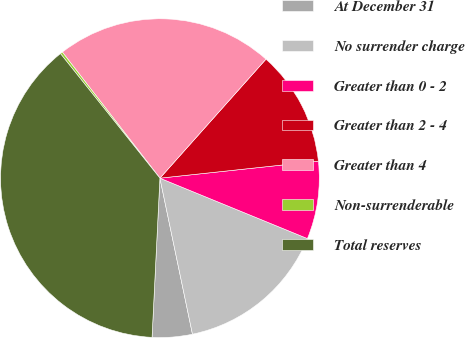<chart> <loc_0><loc_0><loc_500><loc_500><pie_chart><fcel>At December 31<fcel>No surrender charge<fcel>Greater than 0 - 2<fcel>Greater than 2 - 4<fcel>Greater than 4<fcel>Non-surrenderable<fcel>Total reserves<nl><fcel>4.06%<fcel>15.54%<fcel>7.89%<fcel>11.71%<fcel>22.07%<fcel>0.24%<fcel>38.49%<nl></chart> 